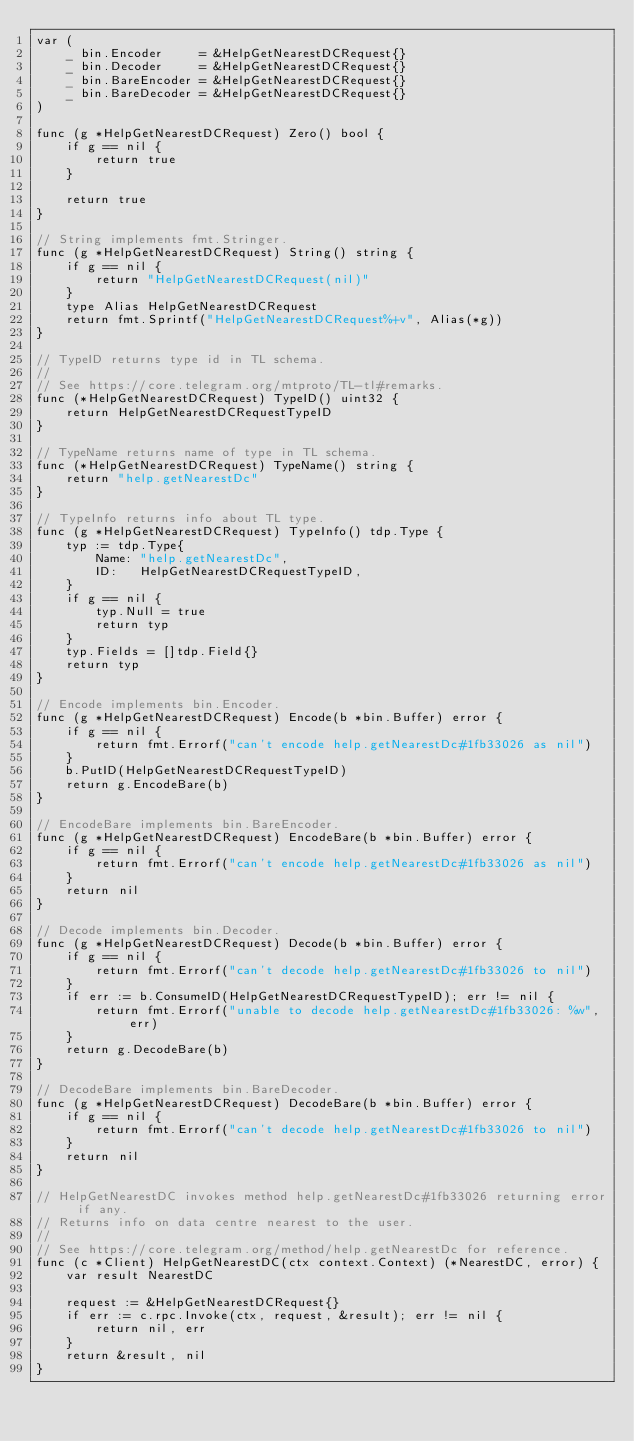Convert code to text. <code><loc_0><loc_0><loc_500><loc_500><_Go_>var (
	_ bin.Encoder     = &HelpGetNearestDCRequest{}
	_ bin.Decoder     = &HelpGetNearestDCRequest{}
	_ bin.BareEncoder = &HelpGetNearestDCRequest{}
	_ bin.BareDecoder = &HelpGetNearestDCRequest{}
)

func (g *HelpGetNearestDCRequest) Zero() bool {
	if g == nil {
		return true
	}

	return true
}

// String implements fmt.Stringer.
func (g *HelpGetNearestDCRequest) String() string {
	if g == nil {
		return "HelpGetNearestDCRequest(nil)"
	}
	type Alias HelpGetNearestDCRequest
	return fmt.Sprintf("HelpGetNearestDCRequest%+v", Alias(*g))
}

// TypeID returns type id in TL schema.
//
// See https://core.telegram.org/mtproto/TL-tl#remarks.
func (*HelpGetNearestDCRequest) TypeID() uint32 {
	return HelpGetNearestDCRequestTypeID
}

// TypeName returns name of type in TL schema.
func (*HelpGetNearestDCRequest) TypeName() string {
	return "help.getNearestDc"
}

// TypeInfo returns info about TL type.
func (g *HelpGetNearestDCRequest) TypeInfo() tdp.Type {
	typ := tdp.Type{
		Name: "help.getNearestDc",
		ID:   HelpGetNearestDCRequestTypeID,
	}
	if g == nil {
		typ.Null = true
		return typ
	}
	typ.Fields = []tdp.Field{}
	return typ
}

// Encode implements bin.Encoder.
func (g *HelpGetNearestDCRequest) Encode(b *bin.Buffer) error {
	if g == nil {
		return fmt.Errorf("can't encode help.getNearestDc#1fb33026 as nil")
	}
	b.PutID(HelpGetNearestDCRequestTypeID)
	return g.EncodeBare(b)
}

// EncodeBare implements bin.BareEncoder.
func (g *HelpGetNearestDCRequest) EncodeBare(b *bin.Buffer) error {
	if g == nil {
		return fmt.Errorf("can't encode help.getNearestDc#1fb33026 as nil")
	}
	return nil
}

// Decode implements bin.Decoder.
func (g *HelpGetNearestDCRequest) Decode(b *bin.Buffer) error {
	if g == nil {
		return fmt.Errorf("can't decode help.getNearestDc#1fb33026 to nil")
	}
	if err := b.ConsumeID(HelpGetNearestDCRequestTypeID); err != nil {
		return fmt.Errorf("unable to decode help.getNearestDc#1fb33026: %w", err)
	}
	return g.DecodeBare(b)
}

// DecodeBare implements bin.BareDecoder.
func (g *HelpGetNearestDCRequest) DecodeBare(b *bin.Buffer) error {
	if g == nil {
		return fmt.Errorf("can't decode help.getNearestDc#1fb33026 to nil")
	}
	return nil
}

// HelpGetNearestDC invokes method help.getNearestDc#1fb33026 returning error if any.
// Returns info on data centre nearest to the user.
//
// See https://core.telegram.org/method/help.getNearestDc for reference.
func (c *Client) HelpGetNearestDC(ctx context.Context) (*NearestDC, error) {
	var result NearestDC

	request := &HelpGetNearestDCRequest{}
	if err := c.rpc.Invoke(ctx, request, &result); err != nil {
		return nil, err
	}
	return &result, nil
}
</code> 